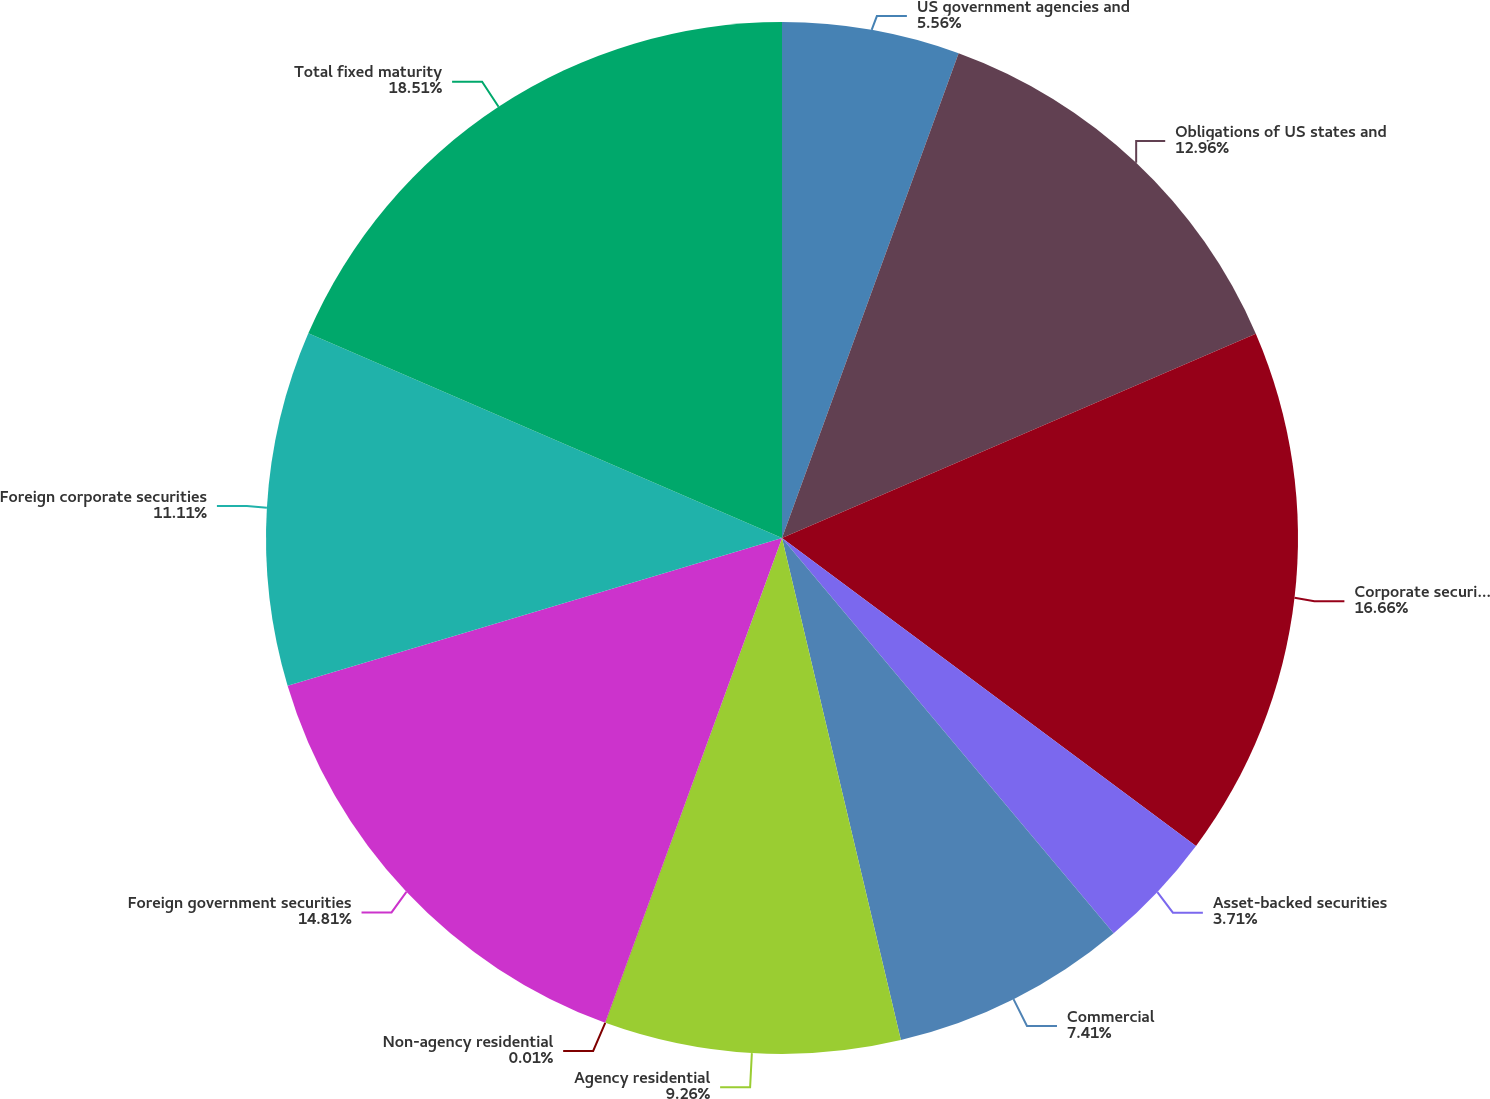Convert chart. <chart><loc_0><loc_0><loc_500><loc_500><pie_chart><fcel>US government agencies and<fcel>Obligations of US states and<fcel>Corporate securities<fcel>Asset-backed securities<fcel>Commercial<fcel>Agency residential<fcel>Non-agency residential<fcel>Foreign government securities<fcel>Foreign corporate securities<fcel>Total fixed maturity<nl><fcel>5.56%<fcel>12.96%<fcel>16.66%<fcel>3.71%<fcel>7.41%<fcel>9.26%<fcel>0.01%<fcel>14.81%<fcel>11.11%<fcel>18.51%<nl></chart> 